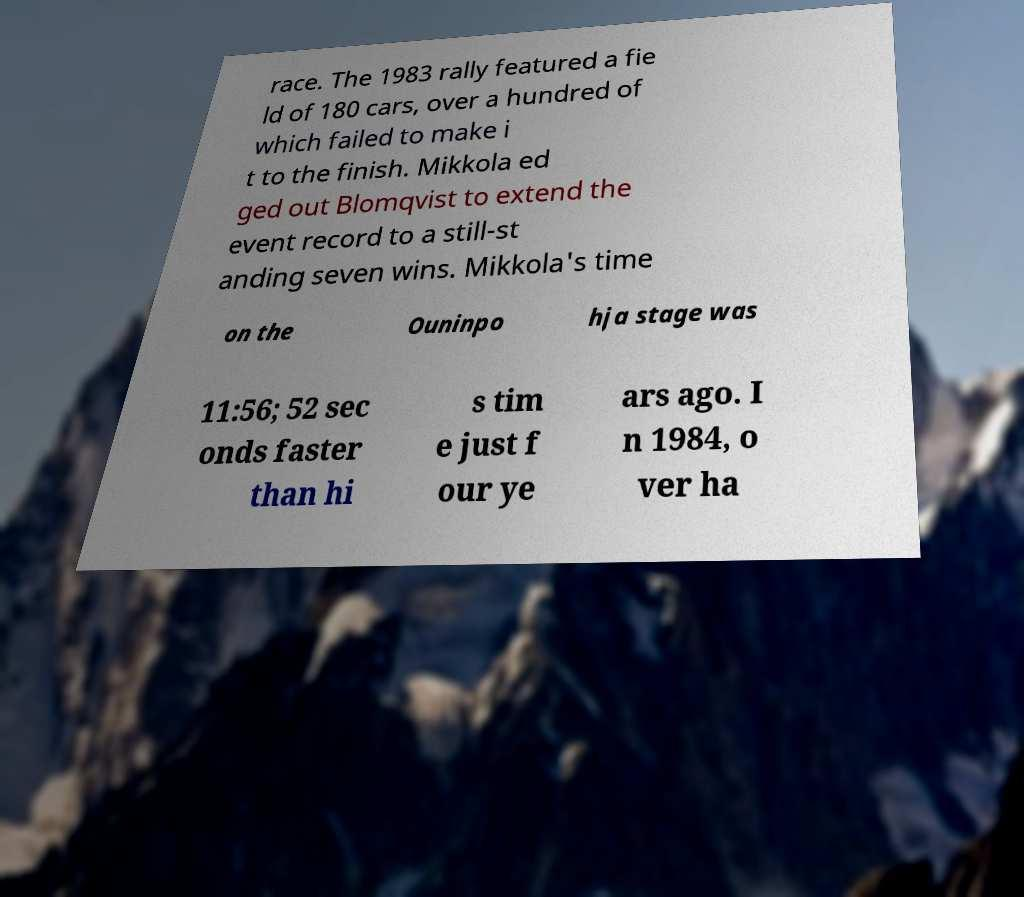Can you accurately transcribe the text from the provided image for me? race. The 1983 rally featured a fie ld of 180 cars, over a hundred of which failed to make i t to the finish. Mikkola ed ged out Blomqvist to extend the event record to a still-st anding seven wins. Mikkola's time on the Ouninpo hja stage was 11:56; 52 sec onds faster than hi s tim e just f our ye ars ago. I n 1984, o ver ha 